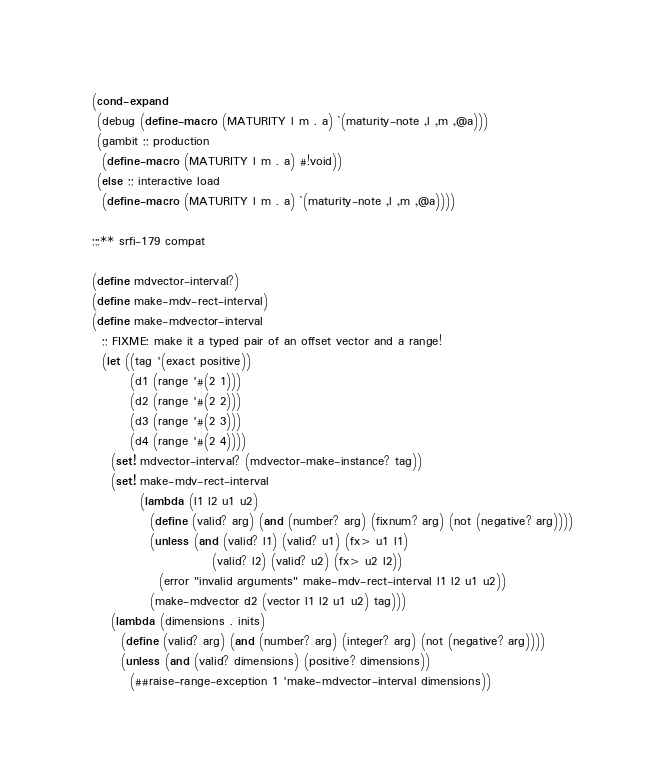Convert code to text. <code><loc_0><loc_0><loc_500><loc_500><_Scheme_>(cond-expand
 (debug (define-macro (MATURITY l m . a) `(maturity-note ,l ,m ,@a)))
 (gambit ;; production
  (define-macro (MATURITY l m . a) #!void))
 (else ;; interactive load
  (define-macro (MATURITY l m . a) `(maturity-note ,l ,m ,@a))))

;;;** srfi-179 compat

(define mdvector-interval?)
(define make-mdv-rect-interval)
(define make-mdvector-interval
  ;; FIXME: make it a typed pair of an offset vector and a range!
  (let ((tag '(exact positive))
        (d1 (range '#(2 1)))
        (d2 (range '#(2 2)))
        (d3 (range '#(2 3)))
        (d4 (range '#(2 4))))
    (set! mdvector-interval? (mdvector-make-instance? tag))
    (set! make-mdv-rect-interval
          (lambda (l1 l2 u1 u2)
            (define (valid? arg) (and (number? arg) (fixnum? arg) (not (negative? arg))))
            (unless (and (valid? l1) (valid? u1) (fx> u1 l1)
                         (valid? l2) (valid? u2) (fx> u2 l2))
              (error "invalid arguments" make-mdv-rect-interval l1 l2 u1 u2))
            (make-mdvector d2 (vector l1 l2 u1 u2) tag)))
    (lambda (dimensions . inits)
      (define (valid? arg) (and (number? arg) (integer? arg) (not (negative? arg))))
      (unless (and (valid? dimensions) (positive? dimensions))
        (##raise-range-exception 1 'make-mdvector-interval dimensions))</code> 